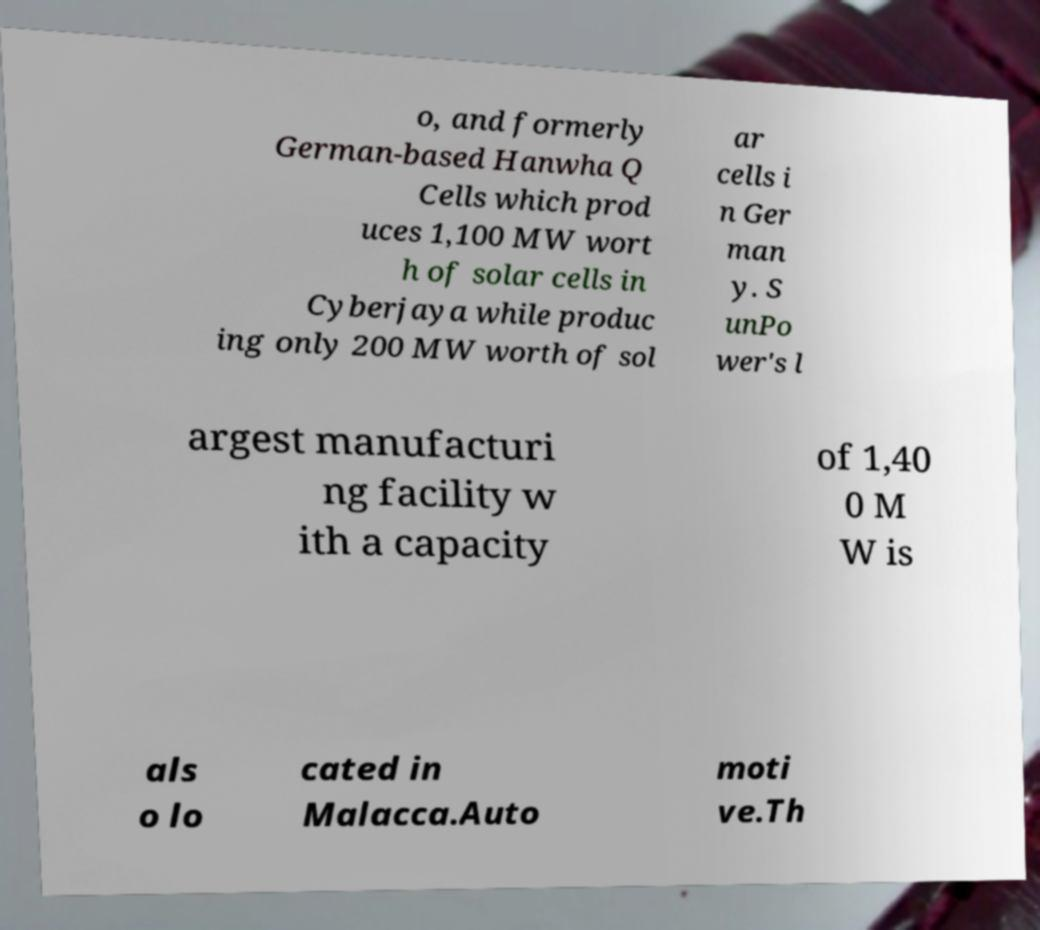Can you read and provide the text displayed in the image?This photo seems to have some interesting text. Can you extract and type it out for me? o, and formerly German-based Hanwha Q Cells which prod uces 1,100 MW wort h of solar cells in Cyberjaya while produc ing only 200 MW worth of sol ar cells i n Ger man y. S unPo wer's l argest manufacturi ng facility w ith a capacity of 1,40 0 M W is als o lo cated in Malacca.Auto moti ve.Th 